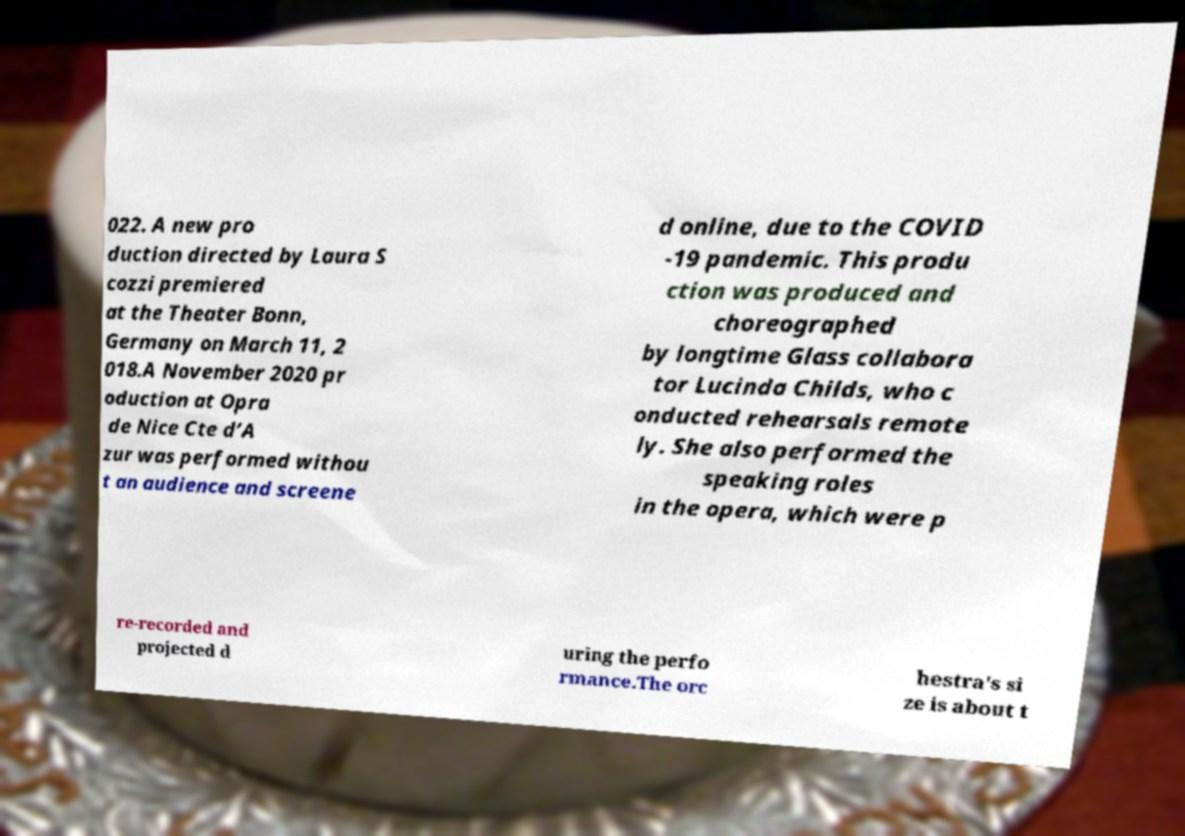Can you read and provide the text displayed in the image?This photo seems to have some interesting text. Can you extract and type it out for me? 022. A new pro duction directed by Laura S cozzi premiered at the Theater Bonn, Germany on March 11, 2 018.A November 2020 pr oduction at Opra de Nice Cte d’A zur was performed withou t an audience and screene d online, due to the COVID -19 pandemic. This produ ction was produced and choreographed by longtime Glass collabora tor Lucinda Childs, who c onducted rehearsals remote ly. She also performed the speaking roles in the opera, which were p re-recorded and projected d uring the perfo rmance.The orc hestra's si ze is about t 